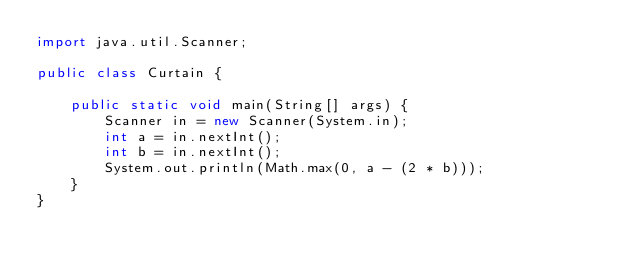<code> <loc_0><loc_0><loc_500><loc_500><_Java_>import java.util.Scanner;

public class Curtain {

    public static void main(String[] args) {
        Scanner in = new Scanner(System.in);
        int a = in.nextInt();
        int b = in.nextInt();
        System.out.println(Math.max(0, a - (2 * b)));
    }
}
</code> 